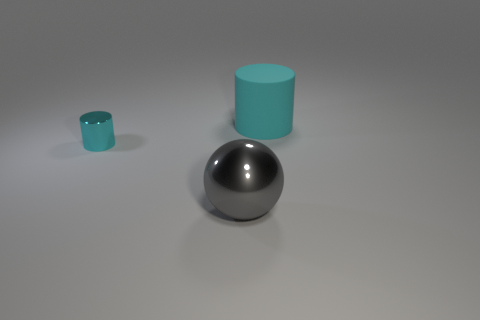How many cyan cylinders must be subtracted to get 1 cyan cylinders? 1 Add 2 gray things. How many objects exist? 5 Subtract all spheres. How many objects are left? 2 Add 1 balls. How many balls exist? 2 Subtract 0 green balls. How many objects are left? 3 Subtract all small cyan cylinders. Subtract all green cylinders. How many objects are left? 2 Add 1 big cylinders. How many big cylinders are left? 2 